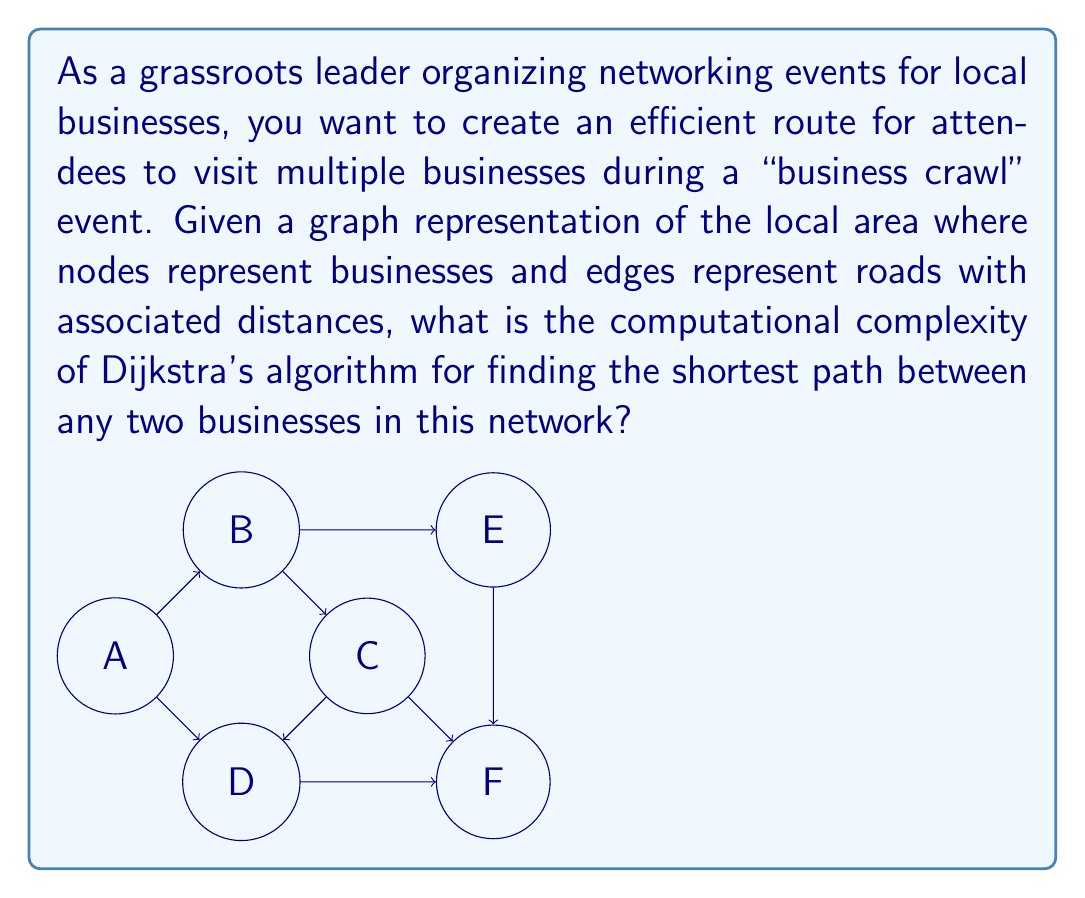Can you solve this math problem? To determine the computational complexity of Dijkstra's algorithm for finding the shortest path between businesses, we need to consider the following steps:

1. Understand the input:
   - Let $V$ be the number of vertices (businesses) in the graph
   - Let $E$ be the number of edges (roads) in the graph

2. Analyze Dijkstra's algorithm:
   a. Initialize distances: $O(V)$
   b. Main loop: Runs $V$ times
   c. For each iteration:
      - Find the minimum distance vertex: $O(V)$
      - Update distances of adjacent vertices: $O(E)$ in total across all iterations

3. Combine the complexities:
   $$O(V) + V \cdot O(V) + O(E) = O(V^2 + E)$$

4. Simplify based on graph properties:
   - In a connected graph, $E \geq V - 1$
   - Therefore, $O(V^2 + E)$ simplifies to $O(V^2)$

5. Consider potential optimizations:
   - Using a min-heap or Fibonacci heap can improve the complexity
   - With a binary min-heap: $O((V + E) \log V)$
   - With a Fibonacci heap: $O(E + V \log V)$

However, for the basic implementation of Dijkstra's algorithm without these optimizations, the computational complexity remains $O(V^2)$.
Answer: $O(V^2)$, where $V$ is the number of businesses 